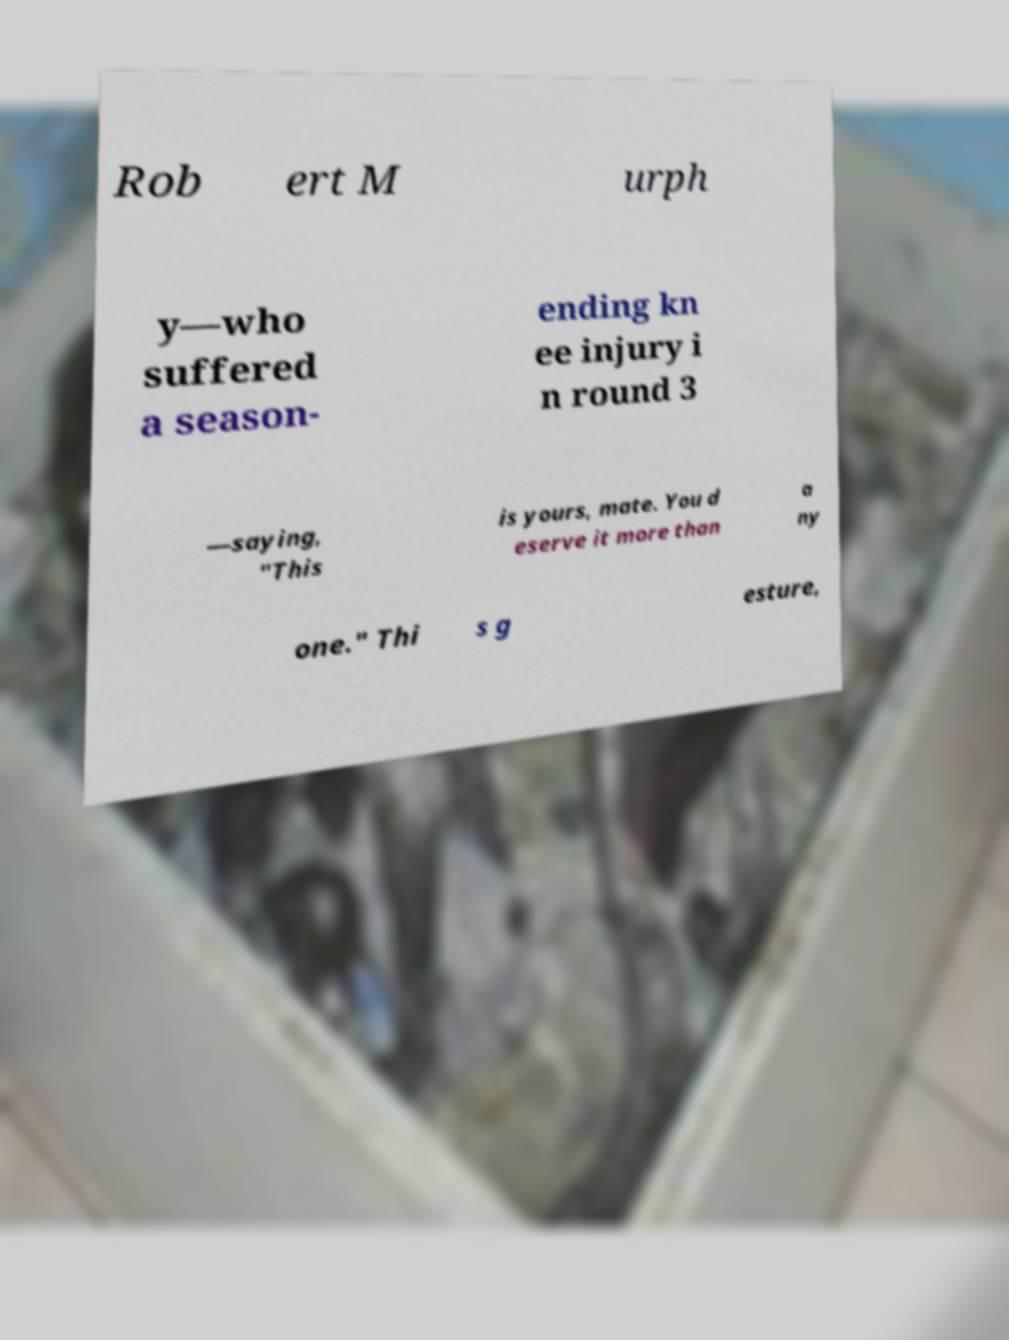Could you assist in decoding the text presented in this image and type it out clearly? Rob ert M urph y—who suffered a season- ending kn ee injury i n round 3 —saying, "This is yours, mate. You d eserve it more than a ny one." Thi s g esture, 